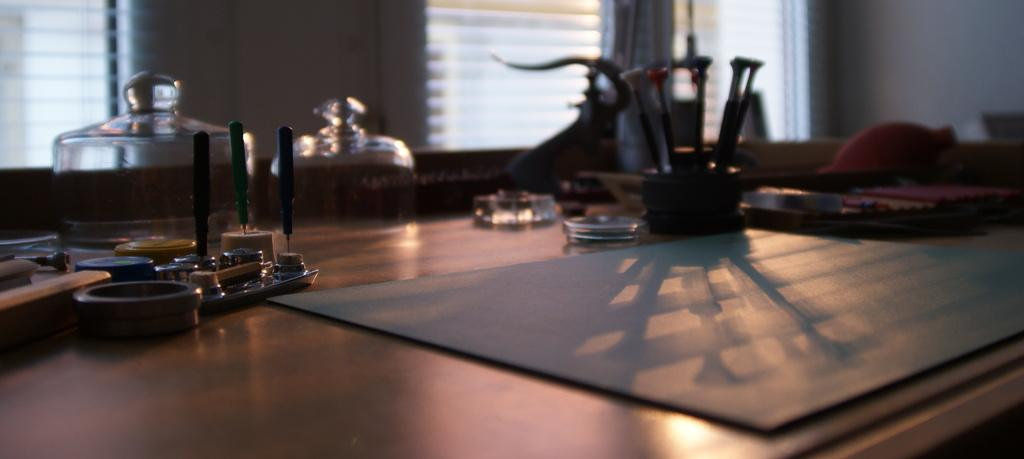What type of furniture is visible in the image? There is a table in the image. What items are placed on the table? There are jars on the table. Can you describe the unique arrangement of spoons in the image? The spoons are in bottles in the image. What other objects can be seen in the image besides the table, jars, and spoons? There are other objects present in the image. What type of basin is used for washing in the image? There is no basin present in the image. How does the sack contribute to the overall composition of the image? There is no sack present in the image. 